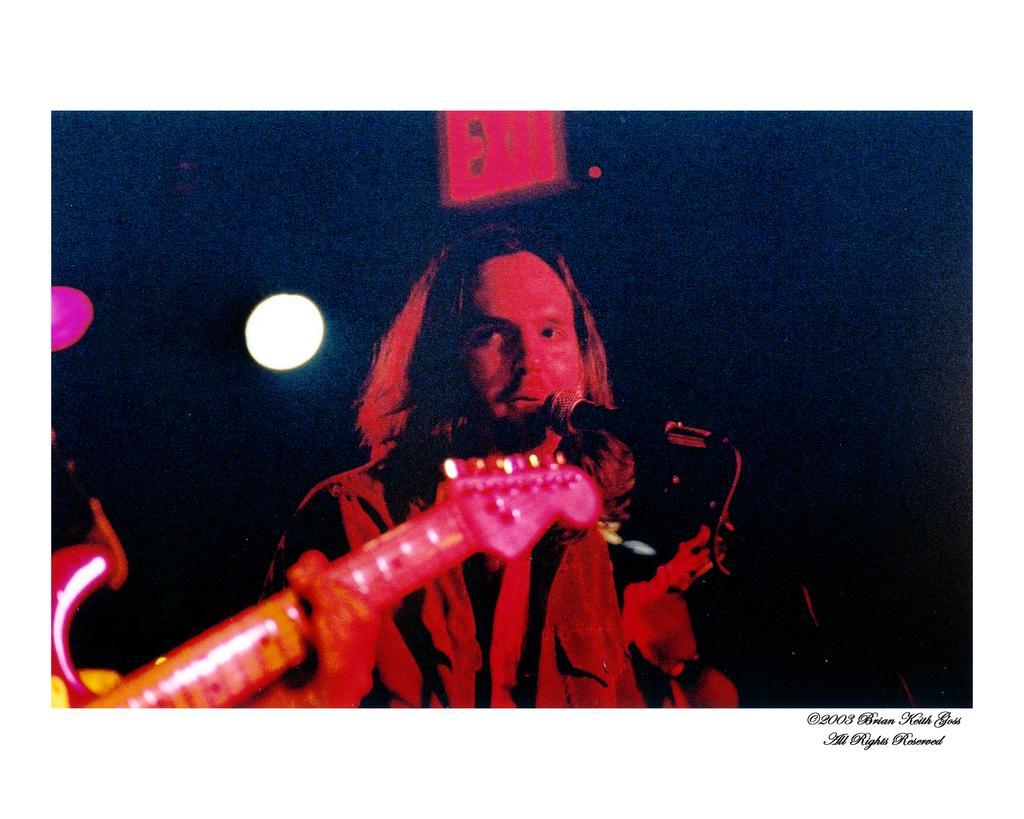Can you describe this image briefly? This image is an edited image. In this image the background is dark. In the middle of the image there is a man holding a mic in the hand. On the left side of the image there is another person holding a guitar in the hand. 